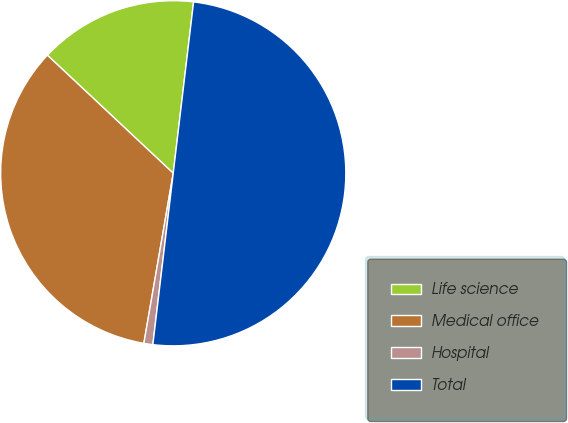Convert chart. <chart><loc_0><loc_0><loc_500><loc_500><pie_chart><fcel>Life science<fcel>Medical office<fcel>Hospital<fcel>Total<nl><fcel>14.89%<fcel>34.27%<fcel>0.84%<fcel>50.0%<nl></chart> 